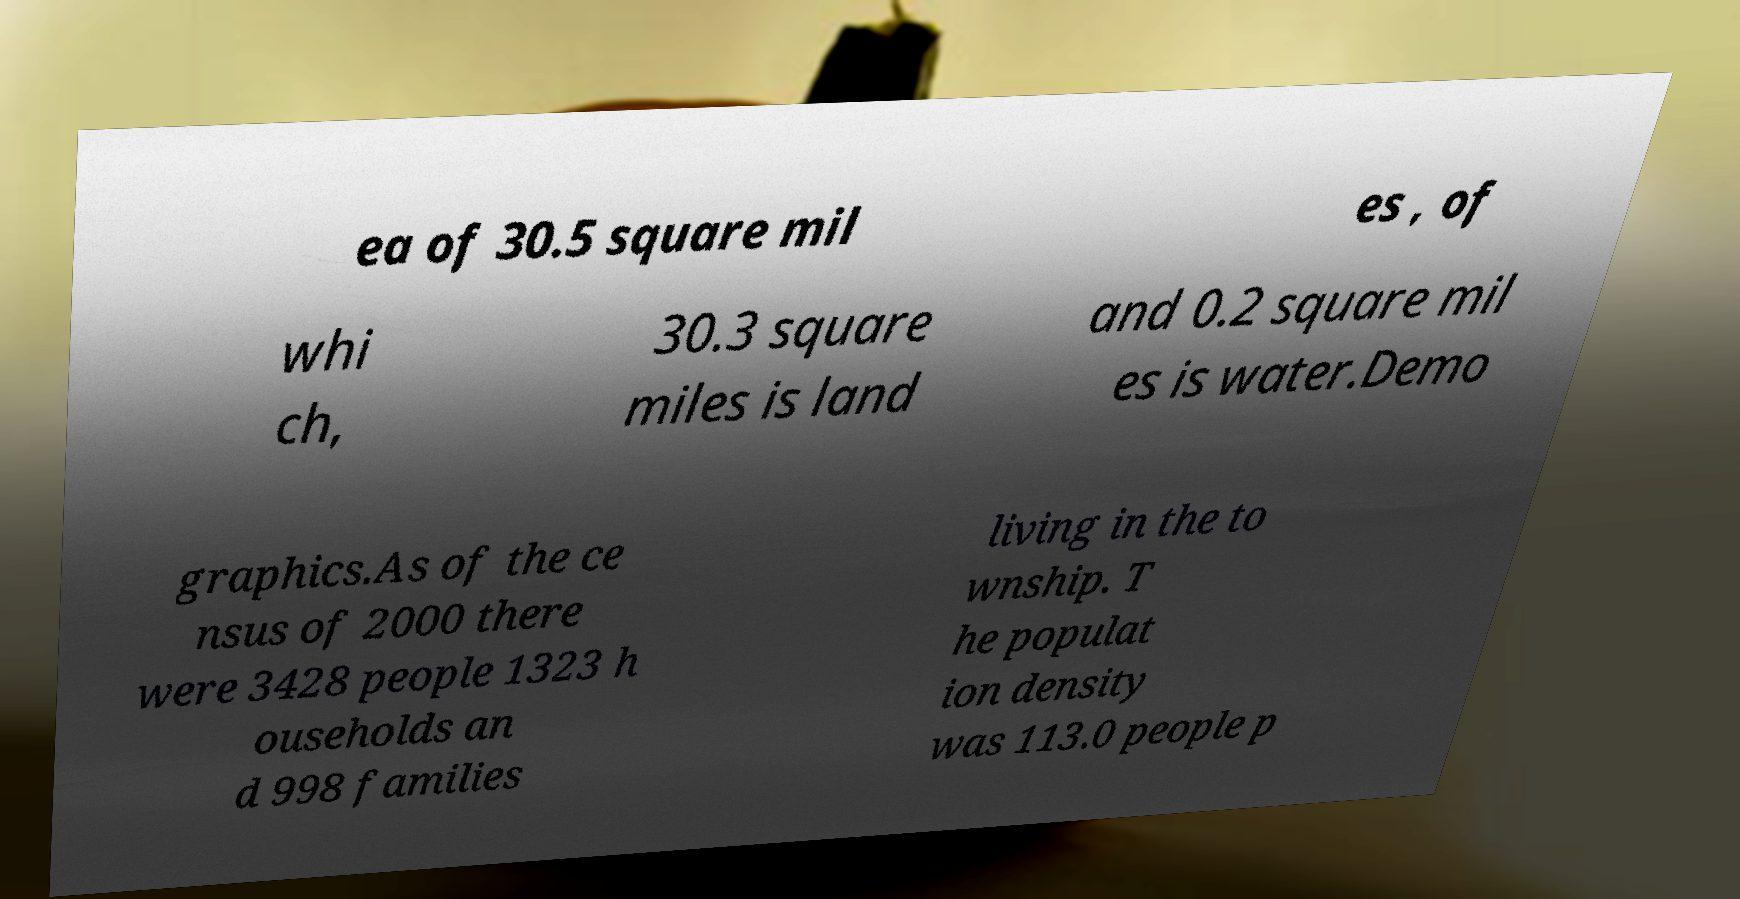Could you assist in decoding the text presented in this image and type it out clearly? ea of 30.5 square mil es , of whi ch, 30.3 square miles is land and 0.2 square mil es is water.Demo graphics.As of the ce nsus of 2000 there were 3428 people 1323 h ouseholds an d 998 families living in the to wnship. T he populat ion density was 113.0 people p 